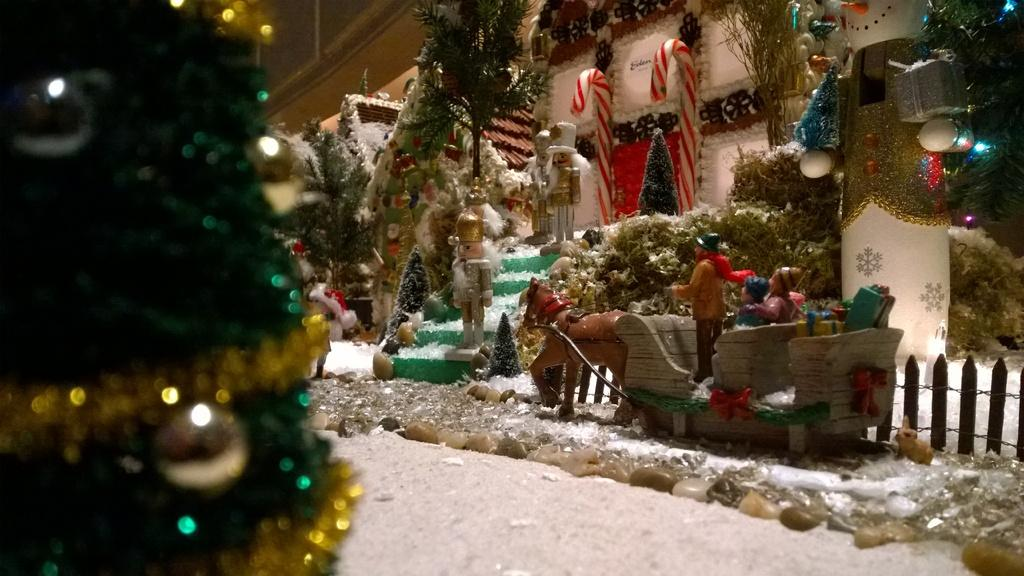What type of objects are present in the image? There is a group of toys and decorated trees in the image. What else can be seen in the image besides the toys and trees? There are decorations in the image. Can you describe the foreground of the image? There are stones in the foreground of the image. Where is the goldfish located in the image? There is no goldfish present in the image. What type of shop can be seen in the image? There is no shop present in the image. 